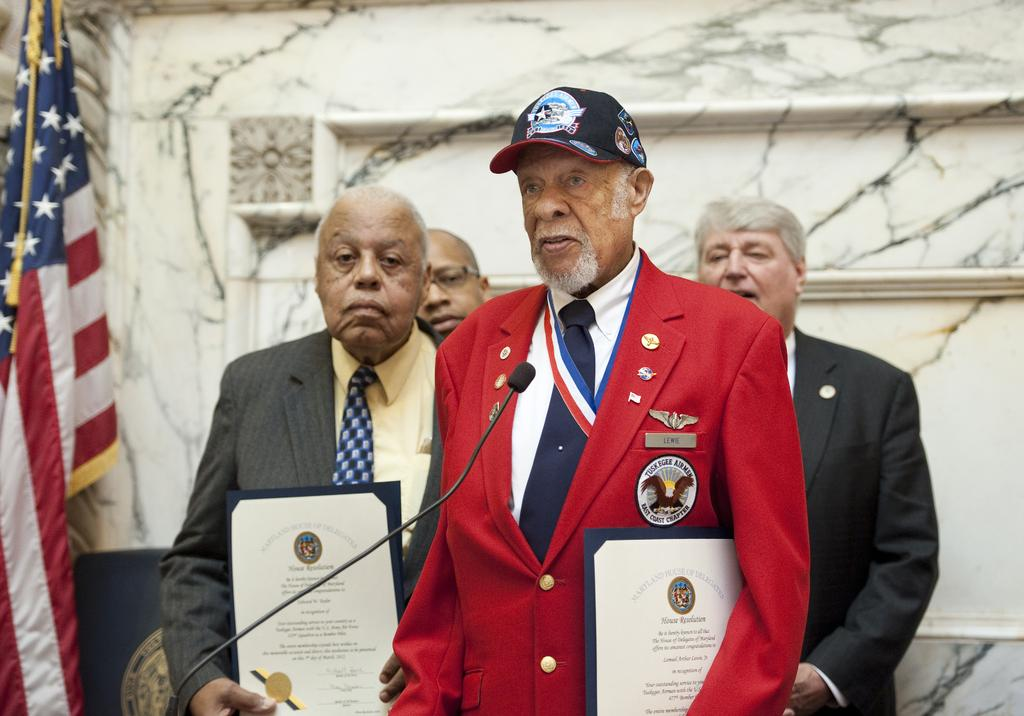How many men are present in the image? There are four men standing in the image. What are two of the men holding? Two of the men are holding certificates. What object can be seen that is typically used for amplifying sound? There appears to be a microphone in the image. What is hanging in the image? A flag is hanging in the image. What can be seen in the background of the image? There is a wall visible in the background of the image. What type of vegetable is being used to clean the floor in the image? There is no vegetable present in the image, nor is there any indication of cleaning or floor maintenance. 